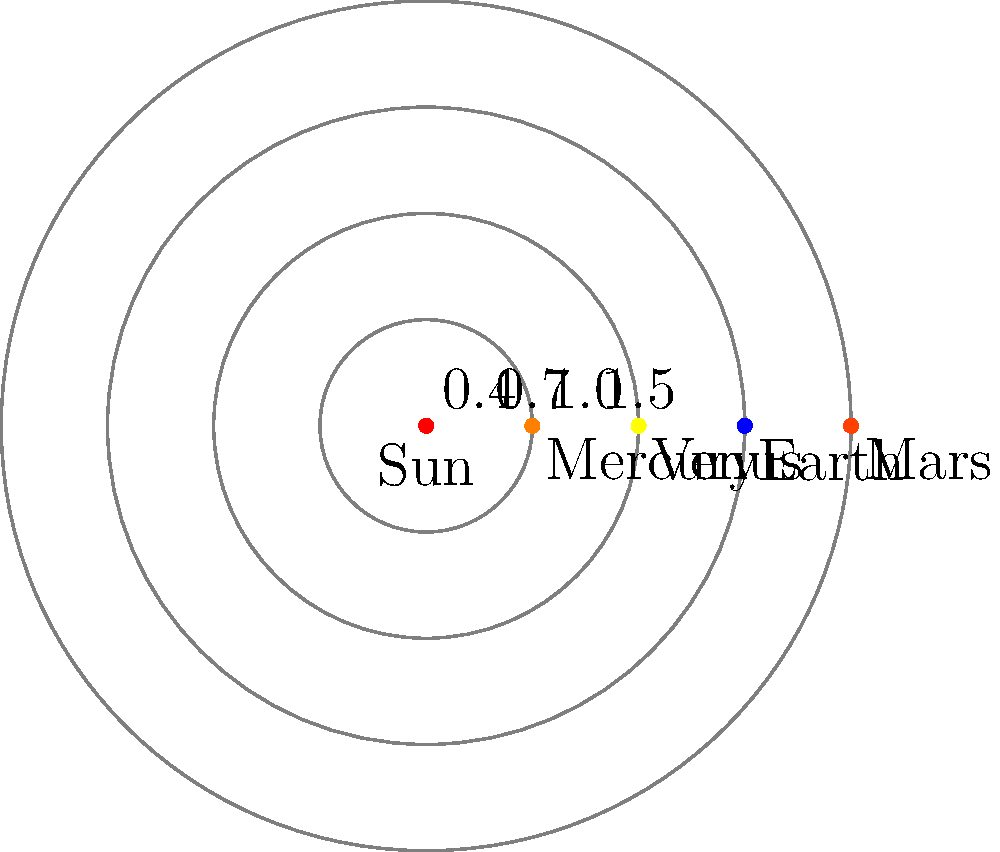In this simplified model of the inner solar system, planets are represented as nodes and their orbits as weighted edges from the Sun. The weights represent the relative distances from the Sun. If we wanted to find the shortest path from the Sun to Mars, visiting all planets along the way, what would be the total weight of this path? To find the shortest path from the Sun to Mars, visiting all planets along the way, we need to follow these steps:

1. Identify the order of planets from closest to farthest from the Sun:
   Sun -> Mercury -> Venus -> Earth -> Mars

2. Sum up the weights of the edges connecting these planets:
   
   a) Sun to Mercury: 0.4
   b) Mercury to Venus: 0.7 - 0.4 = 0.3 (difference in their distances from the Sun)
   c) Venus to Earth: 1.0 - 0.7 = 0.3
   d) Earth to Mars: 1.5 - 1.0 = 0.5

3. Calculate the total weight:
   $$ \text{Total weight} = 0.4 + 0.3 + 0.3 + 0.5 = 1.5 $$

Therefore, the total weight of the shortest path from the Sun to Mars, visiting all planets along the way, is 1.5.
Answer: 1.5 